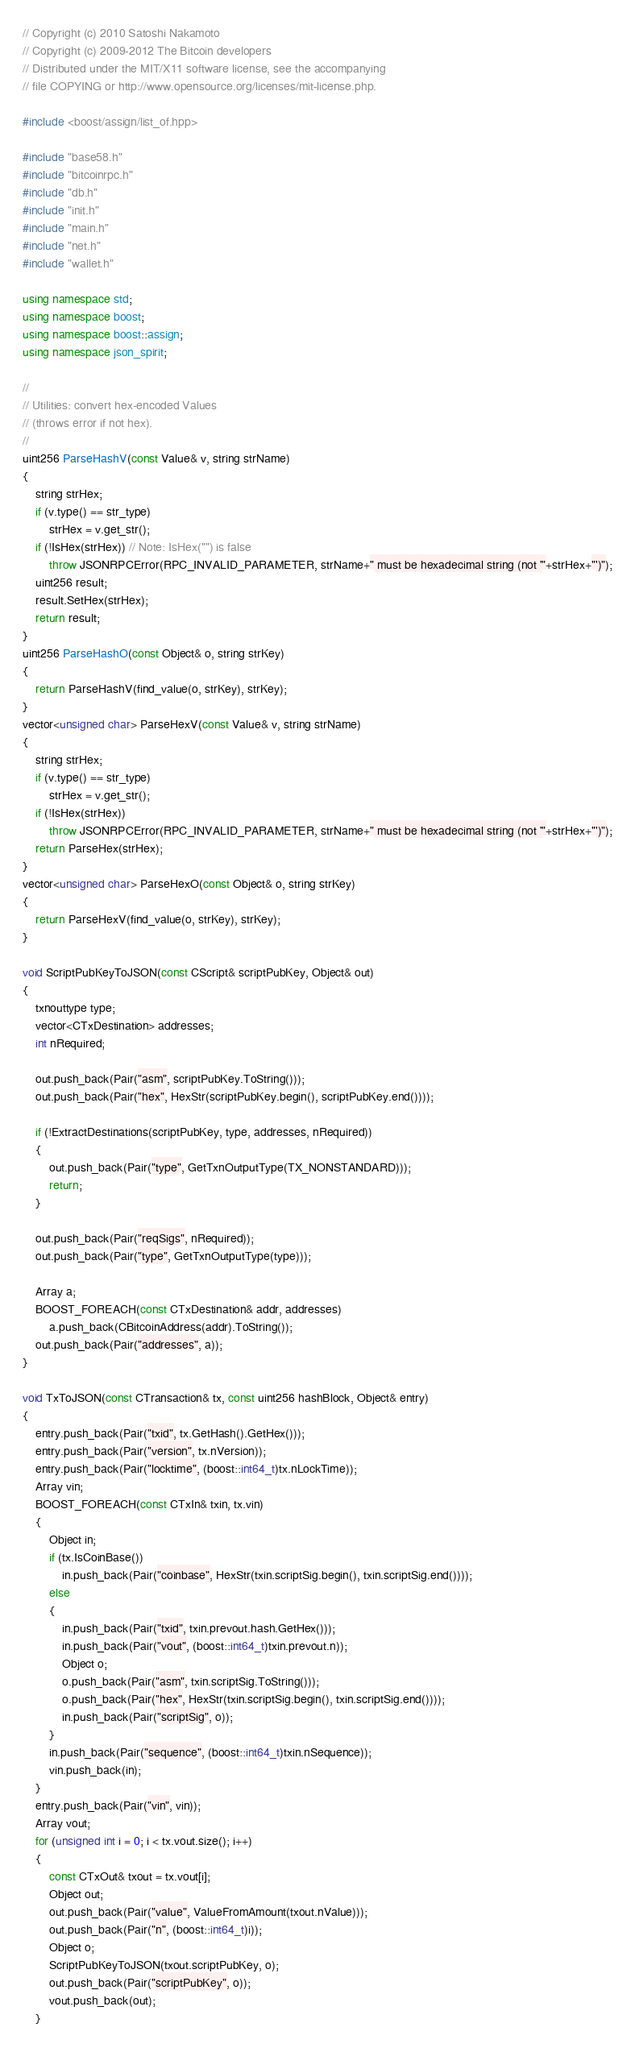<code> <loc_0><loc_0><loc_500><loc_500><_C++_>// Copyright (c) 2010 Satoshi Nakamoto
// Copyright (c) 2009-2012 The Bitcoin developers
// Distributed under the MIT/X11 software license, see the accompanying
// file COPYING or http://www.opensource.org/licenses/mit-license.php.

#include <boost/assign/list_of.hpp>

#include "base58.h"
#include "bitcoinrpc.h"
#include "db.h"
#include "init.h"
#include "main.h"
#include "net.h"
#include "wallet.h"

using namespace std;
using namespace boost;
using namespace boost::assign;
using namespace json_spirit;

//
// Utilities: convert hex-encoded Values
// (throws error if not hex).
//
uint256 ParseHashV(const Value& v, string strName)
{
    string strHex;
    if (v.type() == str_type)
        strHex = v.get_str();
    if (!IsHex(strHex)) // Note: IsHex("") is false
        throw JSONRPCError(RPC_INVALID_PARAMETER, strName+" must be hexadecimal string (not '"+strHex+"')");
    uint256 result;
    result.SetHex(strHex);
    return result;
}
uint256 ParseHashO(const Object& o, string strKey)
{
    return ParseHashV(find_value(o, strKey), strKey);
}
vector<unsigned char> ParseHexV(const Value& v, string strName)
{
    string strHex;
    if (v.type() == str_type)
        strHex = v.get_str();
    if (!IsHex(strHex))
        throw JSONRPCError(RPC_INVALID_PARAMETER, strName+" must be hexadecimal string (not '"+strHex+"')");
    return ParseHex(strHex);
}
vector<unsigned char> ParseHexO(const Object& o, string strKey)
{
    return ParseHexV(find_value(o, strKey), strKey);
}

void ScriptPubKeyToJSON(const CScript& scriptPubKey, Object& out)
{
    txnouttype type;
    vector<CTxDestination> addresses;
    int nRequired;

    out.push_back(Pair("asm", scriptPubKey.ToString()));
    out.push_back(Pair("hex", HexStr(scriptPubKey.begin(), scriptPubKey.end())));

    if (!ExtractDestinations(scriptPubKey, type, addresses, nRequired))
    {
        out.push_back(Pair("type", GetTxnOutputType(TX_NONSTANDARD)));
        return;
    }

    out.push_back(Pair("reqSigs", nRequired));
    out.push_back(Pair("type", GetTxnOutputType(type)));

    Array a;
    BOOST_FOREACH(const CTxDestination& addr, addresses)
        a.push_back(CBitcoinAddress(addr).ToString());
    out.push_back(Pair("addresses", a));
}

void TxToJSON(const CTransaction& tx, const uint256 hashBlock, Object& entry)
{
    entry.push_back(Pair("txid", tx.GetHash().GetHex()));
    entry.push_back(Pair("version", tx.nVersion));
    entry.push_back(Pair("locktime", (boost::int64_t)tx.nLockTime));
    Array vin;
    BOOST_FOREACH(const CTxIn& txin, tx.vin)
    {
        Object in;
        if (tx.IsCoinBase())
            in.push_back(Pair("coinbase", HexStr(txin.scriptSig.begin(), txin.scriptSig.end())));
        else
        {
            in.push_back(Pair("txid", txin.prevout.hash.GetHex()));
            in.push_back(Pair("vout", (boost::int64_t)txin.prevout.n));
            Object o;
            o.push_back(Pair("asm", txin.scriptSig.ToString()));
            o.push_back(Pair("hex", HexStr(txin.scriptSig.begin(), txin.scriptSig.end())));
            in.push_back(Pair("scriptSig", o));
        }
        in.push_back(Pair("sequence", (boost::int64_t)txin.nSequence));
        vin.push_back(in);
    }
    entry.push_back(Pair("vin", vin));
    Array vout;
    for (unsigned int i = 0; i < tx.vout.size(); i++)
    {
        const CTxOut& txout = tx.vout[i];
        Object out;
        out.push_back(Pair("value", ValueFromAmount(txout.nValue)));
        out.push_back(Pair("n", (boost::int64_t)i));
        Object o;
        ScriptPubKeyToJSON(txout.scriptPubKey, o);
        out.push_back(Pair("scriptPubKey", o));
        vout.push_back(out);
    }</code> 